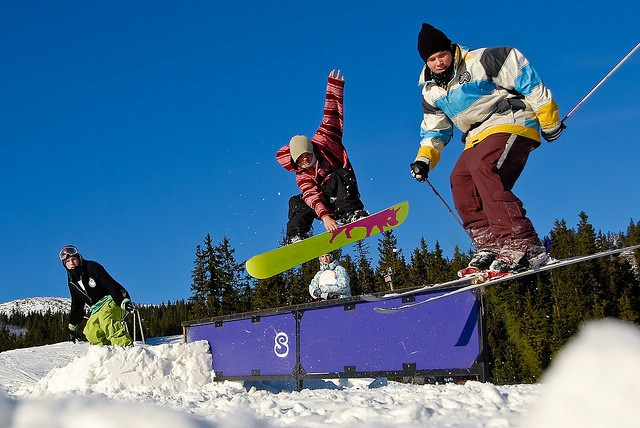Describe the objects in this image and their specific colors. I can see people in blue, black, maroon, and beige tones, people in blue, black, maroon, gray, and lightpink tones, people in blue, black, darkgreen, olive, and khaki tones, snowboard in blue, olive, purple, and black tones, and skis in blue, black, gray, and darkgray tones in this image. 